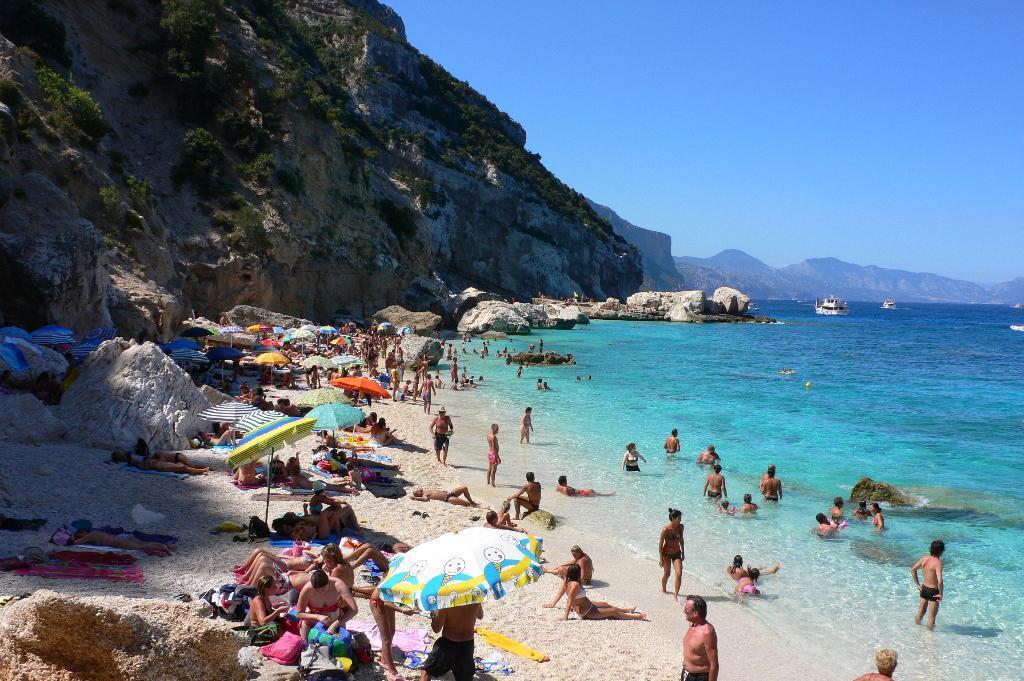Please provide a concise description of this image. Here we can see many people on the sand where few are lying,sitting and walking on the sand and we can also see umbrellas and few persons are in the water. In the background there are ships on the water,mountains and sky. 